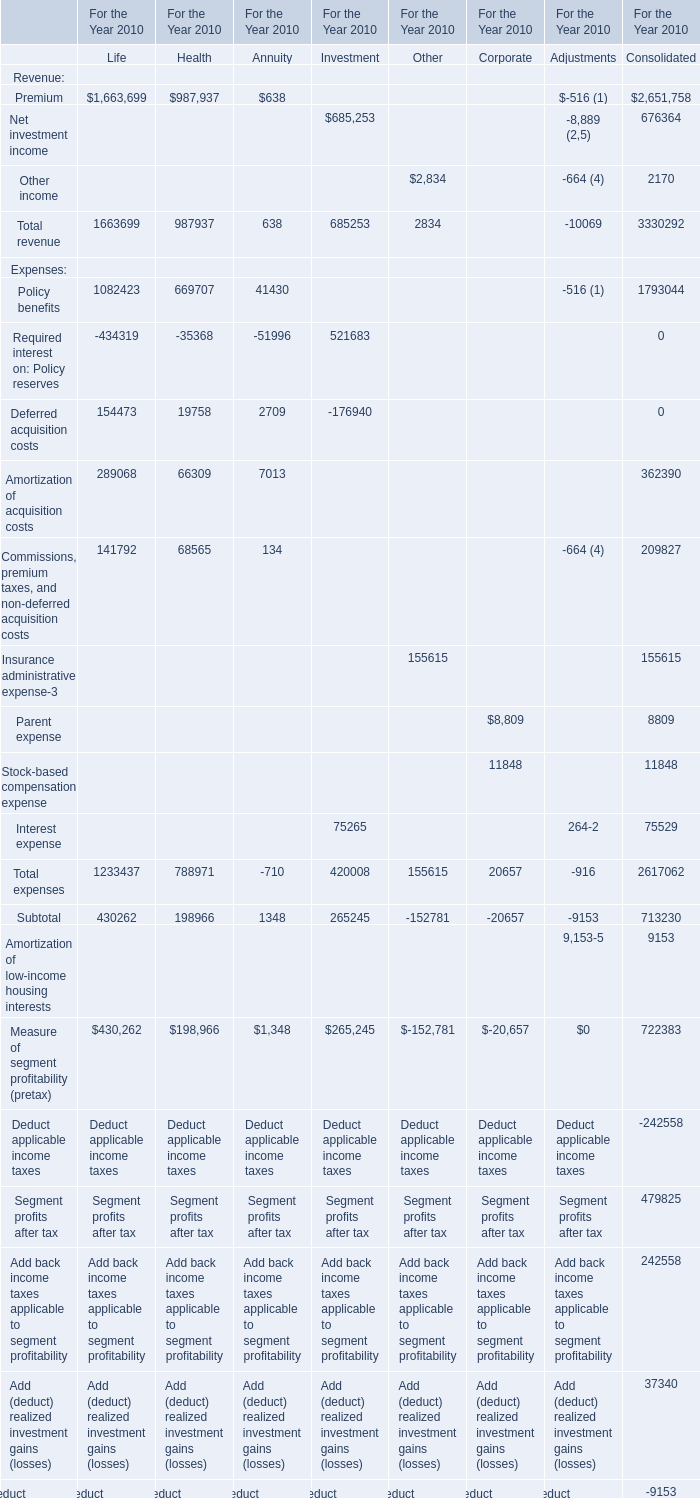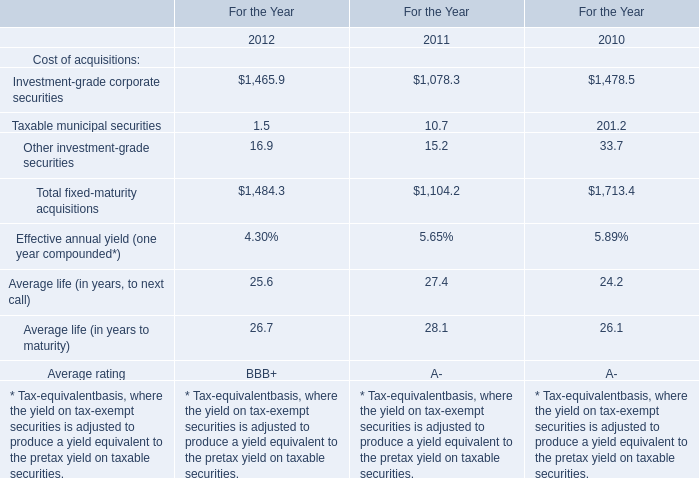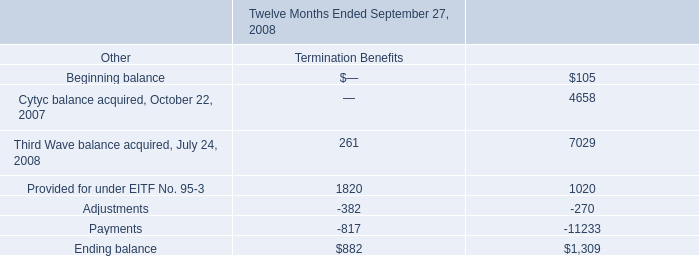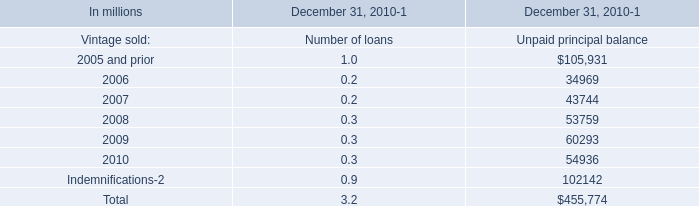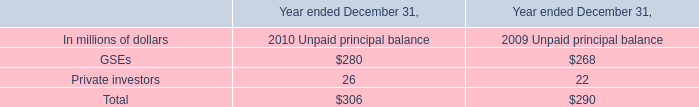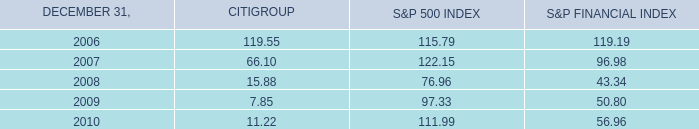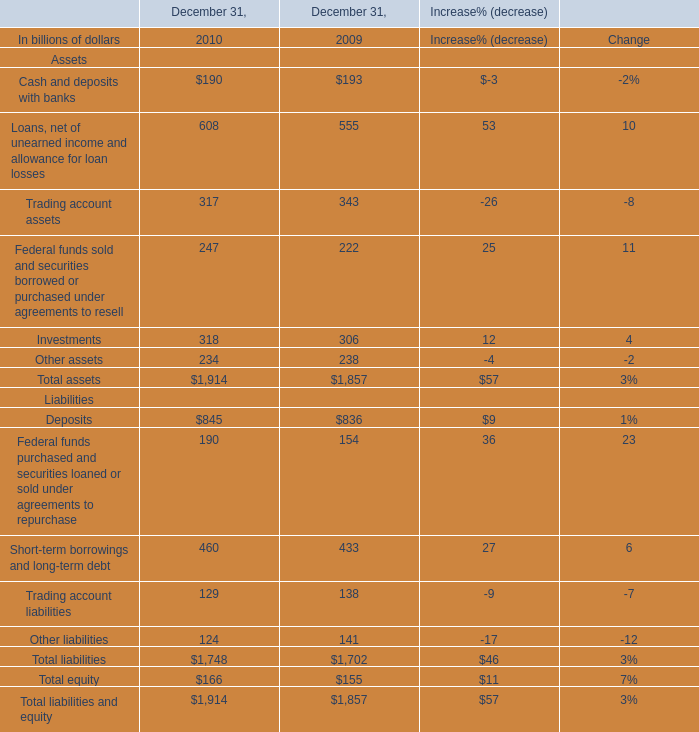what is the growth rate in advertising costs from 2006 to 2007? 
Computations: ((6683 - 5003) / 5003)
Answer: 0.3358. 